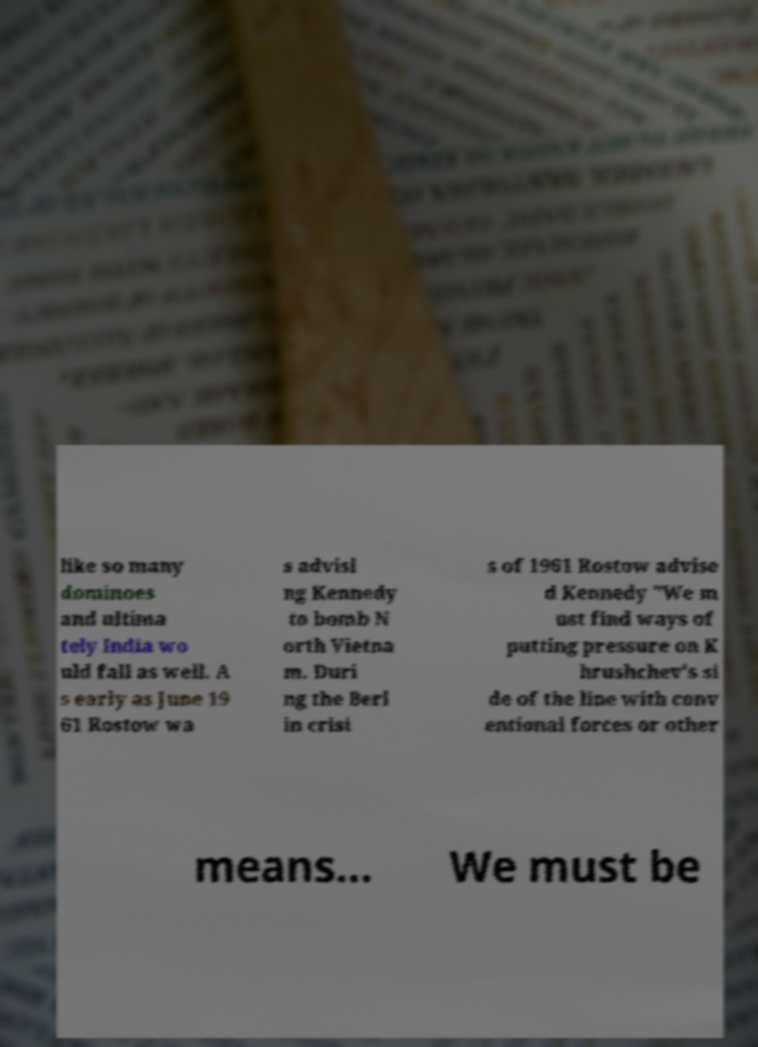For documentation purposes, I need the text within this image transcribed. Could you provide that? like so many dominoes and ultima tely India wo uld fall as well. A s early as June 19 61 Rostow wa s advisi ng Kennedy to bomb N orth Vietna m. Duri ng the Berl in crisi s of 1961 Rostow advise d Kennedy "We m ust find ways of putting pressure on K hrushchev's si de of the line with conv entional forces or other means... We must be 